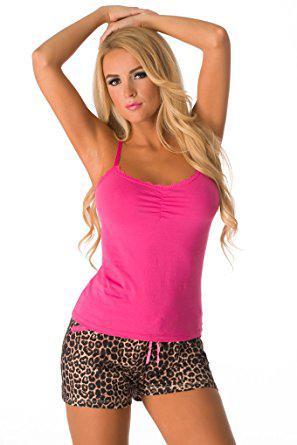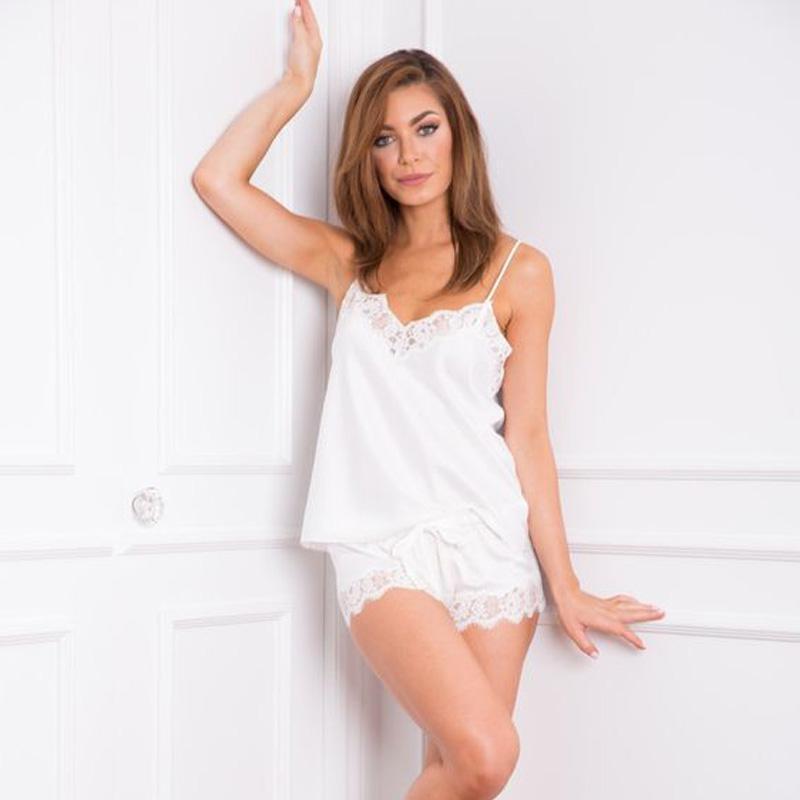The first image is the image on the left, the second image is the image on the right. Evaluate the accuracy of this statement regarding the images: "One model is wearing a shiny pink matching camisole top and short shorts.". Is it true? Answer yes or no. No. The first image is the image on the left, the second image is the image on the right. Analyze the images presented: Is the assertion "A woman is wearing a silky shiny pink sleepwear." valid? Answer yes or no. No. 